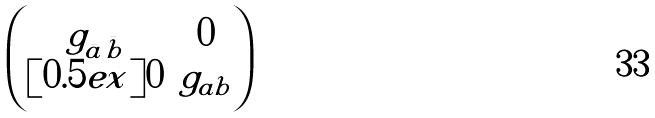<formula> <loc_0><loc_0><loc_500><loc_500>\begin{pmatrix} { g } _ { \bar { a } \bar { b } } & 0 \\ [ 0 . 5 e x ] 0 & { g } _ { a b } \end{pmatrix}</formula> 